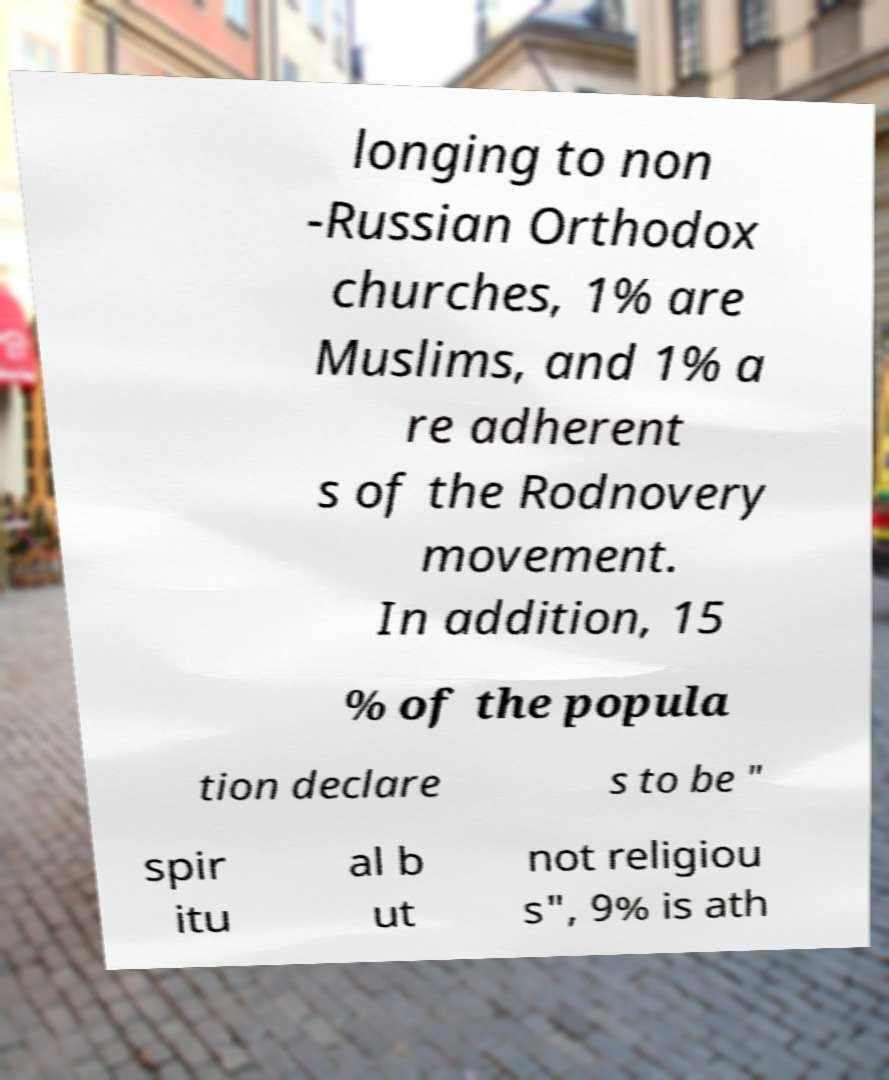Please identify and transcribe the text found in this image. longing to non -Russian Orthodox churches, 1% are Muslims, and 1% a re adherent s of the Rodnovery movement. In addition, 15 % of the popula tion declare s to be " spir itu al b ut not religiou s", 9% is ath 